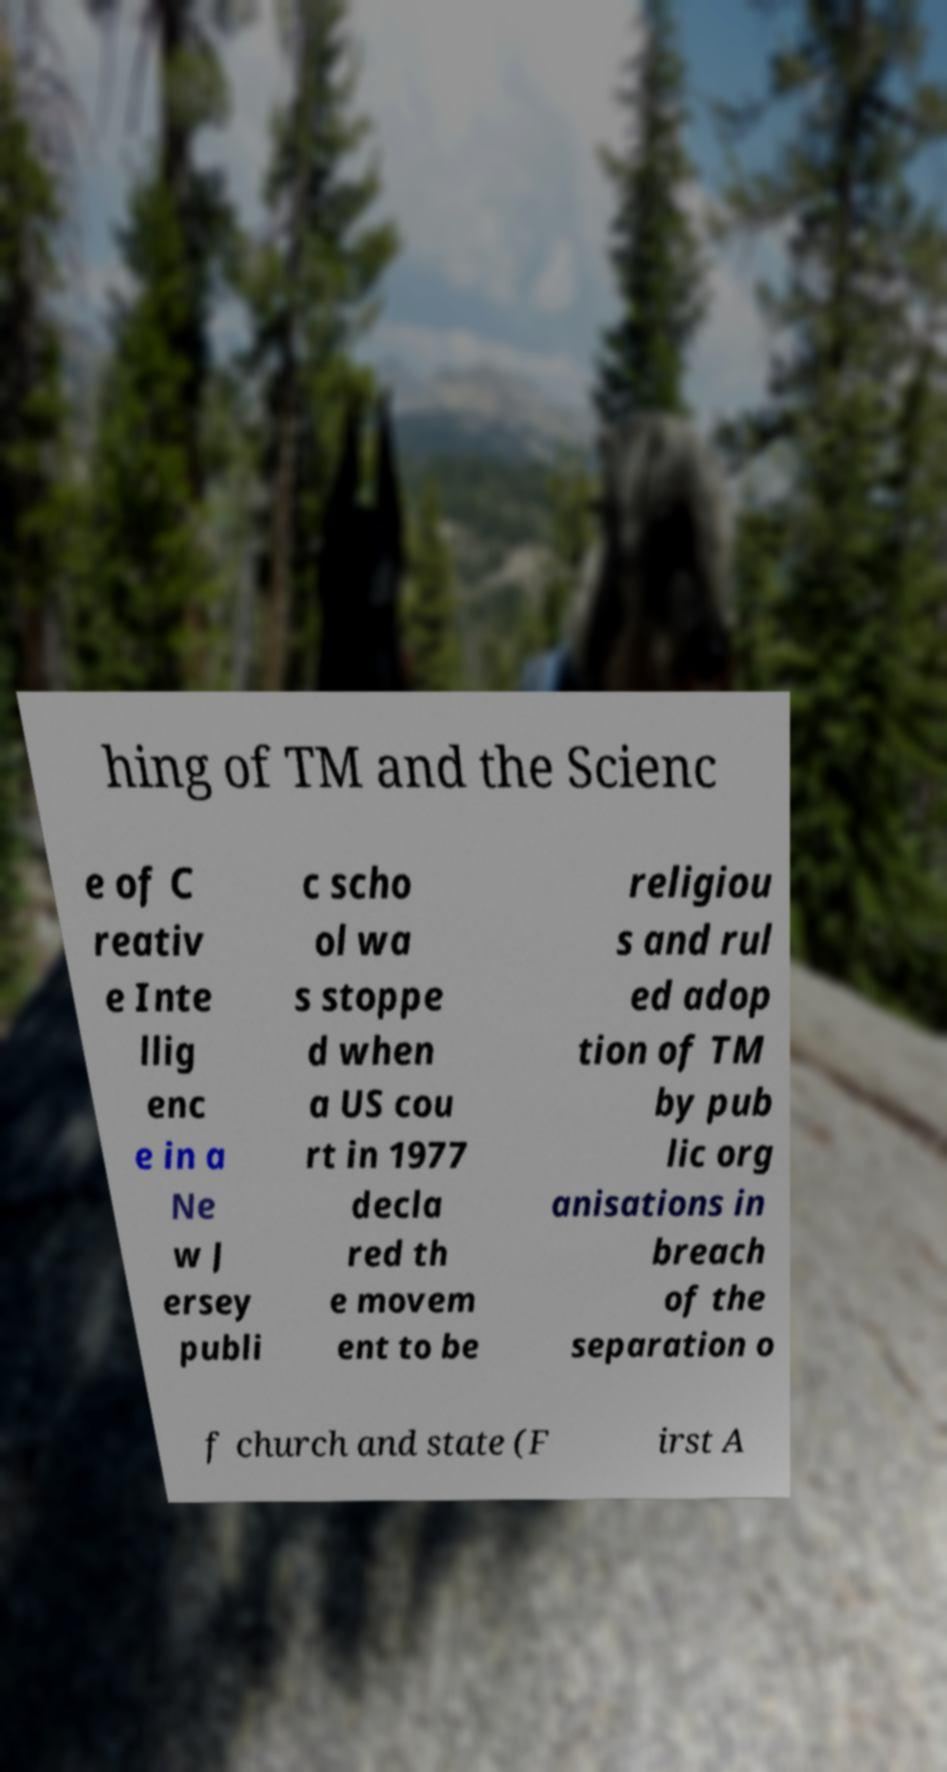What messages or text are displayed in this image? I need them in a readable, typed format. hing of TM and the Scienc e of C reativ e Inte llig enc e in a Ne w J ersey publi c scho ol wa s stoppe d when a US cou rt in 1977 decla red th e movem ent to be religiou s and rul ed adop tion of TM by pub lic org anisations in breach of the separation o f church and state (F irst A 